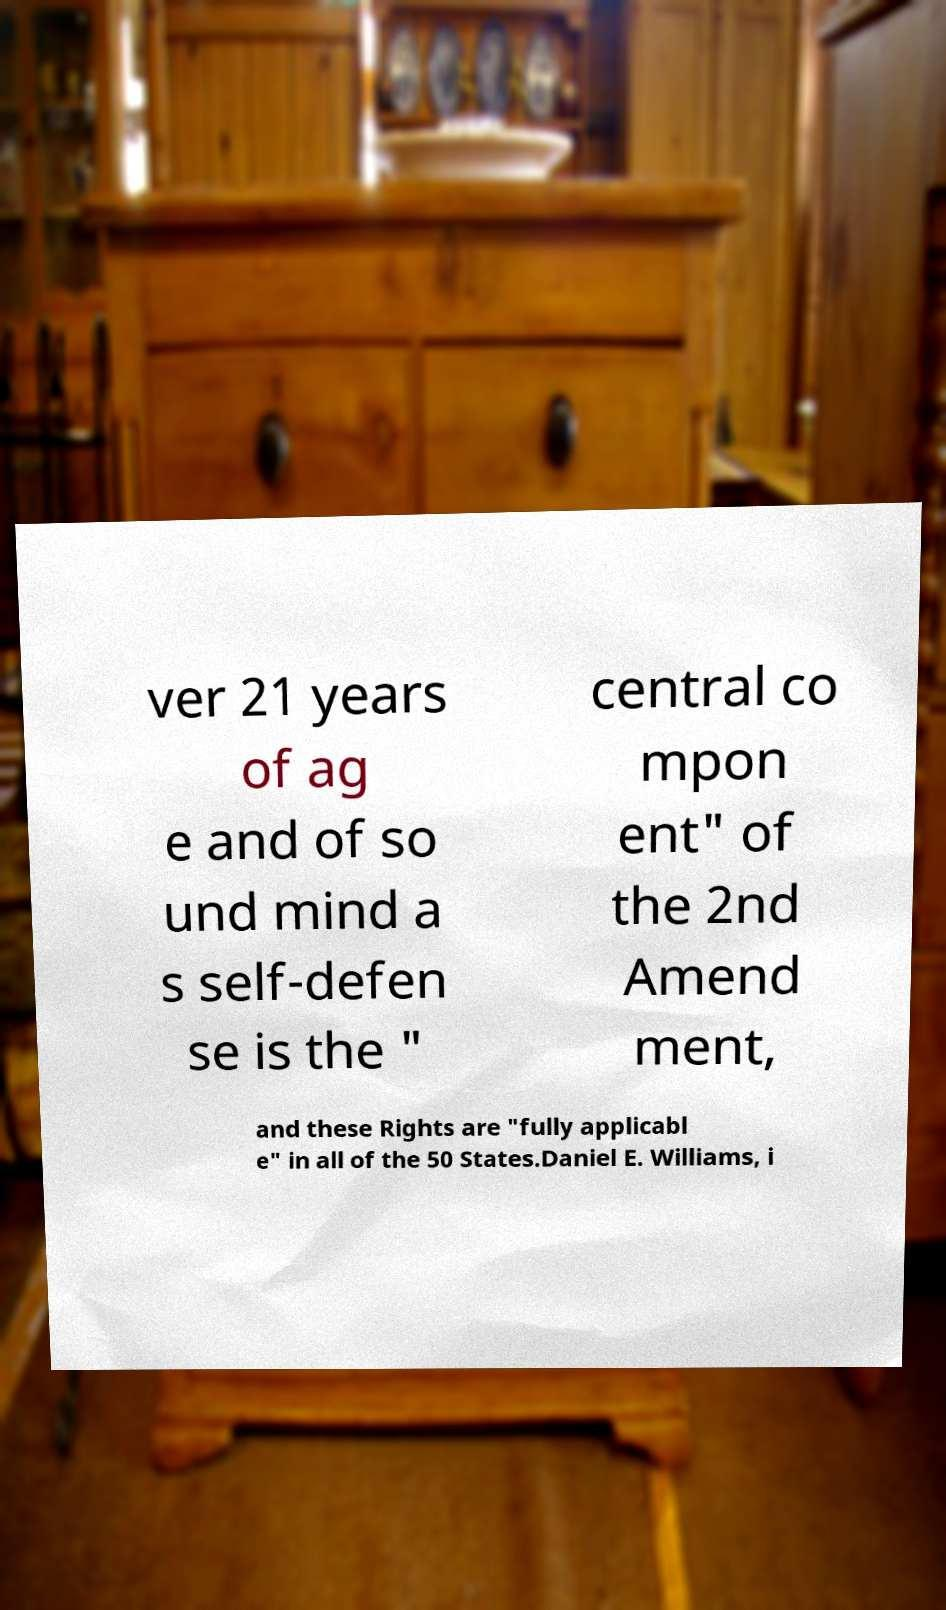What messages or text are displayed in this image? I need them in a readable, typed format. ver 21 years of ag e and of so und mind a s self-defen se is the " central co mpon ent" of the 2nd Amend ment, and these Rights are "fully applicabl e" in all of the 50 States.Daniel E. Williams, i 